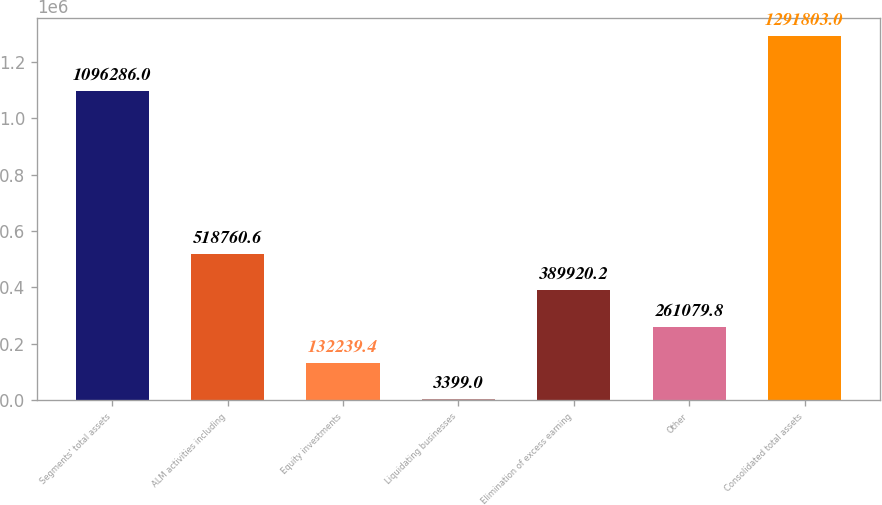Convert chart to OTSL. <chart><loc_0><loc_0><loc_500><loc_500><bar_chart><fcel>Segments' total assets<fcel>ALM activities including<fcel>Equity investments<fcel>Liquidating businesses<fcel>Elimination of excess earning<fcel>Other<fcel>Consolidated total assets<nl><fcel>1.09629e+06<fcel>518761<fcel>132239<fcel>3399<fcel>389920<fcel>261080<fcel>1.2918e+06<nl></chart> 